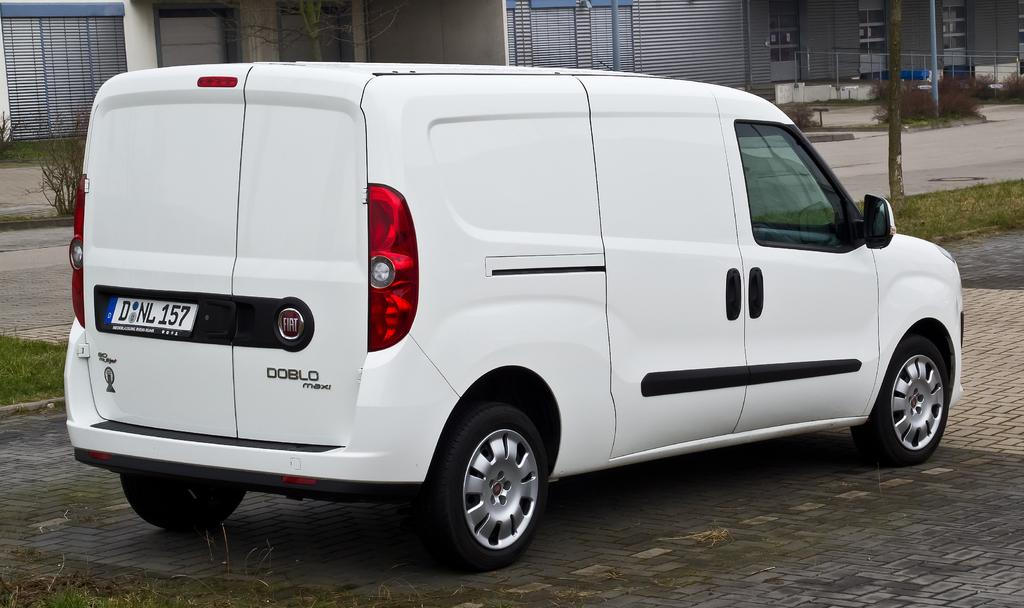<image>
Present a compact description of the photo's key features. A white Doblo Maxi van with a D NL 157 license plate. 